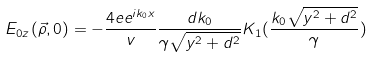Convert formula to latex. <formula><loc_0><loc_0><loc_500><loc_500>E _ { 0 z } ( \vec { \rho } , 0 ) = - \frac { 4 e e ^ { i k _ { 0 } x } } { v } \frac { d k _ { 0 } } { \gamma \sqrt { y ^ { 2 } + d ^ { 2 } } } K _ { 1 } ( \frac { k _ { 0 } \sqrt { y ^ { 2 } + d ^ { 2 } } } { \gamma } )</formula> 